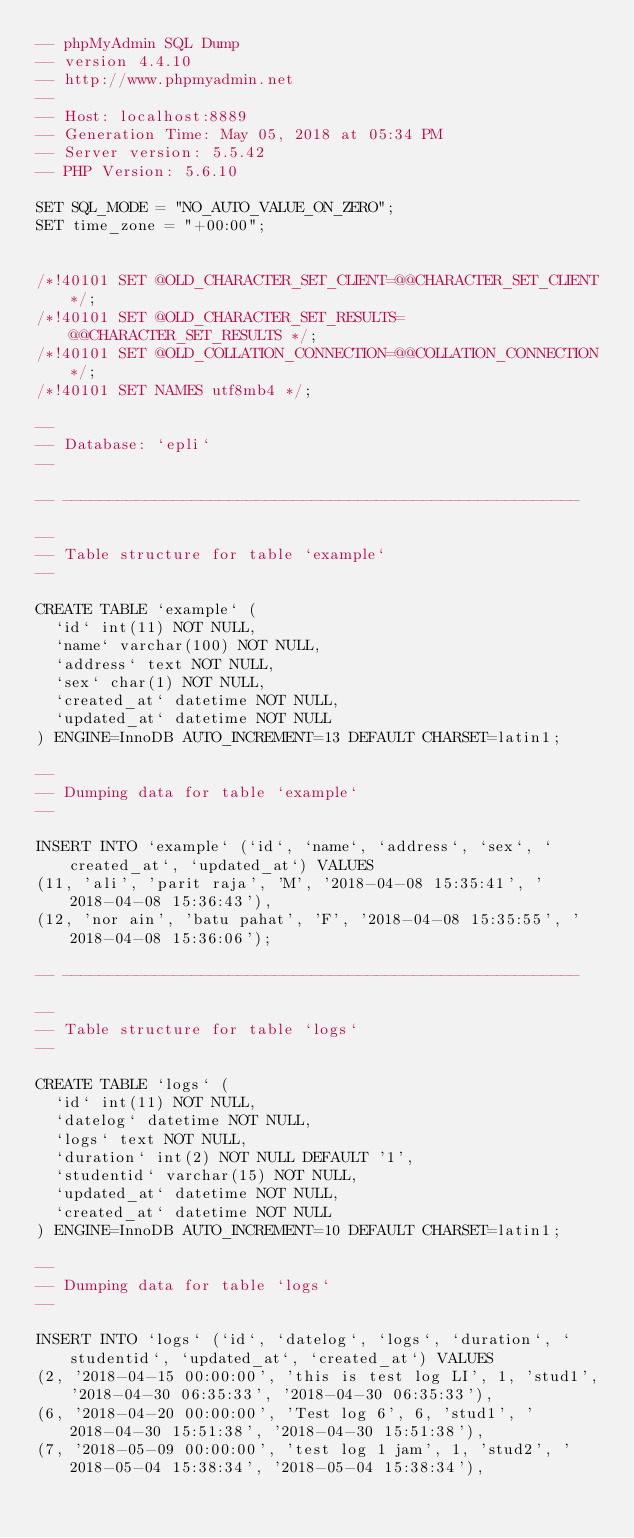Convert code to text. <code><loc_0><loc_0><loc_500><loc_500><_SQL_>-- phpMyAdmin SQL Dump
-- version 4.4.10
-- http://www.phpmyadmin.net
--
-- Host: localhost:8889
-- Generation Time: May 05, 2018 at 05:34 PM
-- Server version: 5.5.42
-- PHP Version: 5.6.10

SET SQL_MODE = "NO_AUTO_VALUE_ON_ZERO";
SET time_zone = "+00:00";


/*!40101 SET @OLD_CHARACTER_SET_CLIENT=@@CHARACTER_SET_CLIENT */;
/*!40101 SET @OLD_CHARACTER_SET_RESULTS=@@CHARACTER_SET_RESULTS */;
/*!40101 SET @OLD_COLLATION_CONNECTION=@@COLLATION_CONNECTION */;
/*!40101 SET NAMES utf8mb4 */;

--
-- Database: `epli`
--

-- --------------------------------------------------------

--
-- Table structure for table `example`
--

CREATE TABLE `example` (
  `id` int(11) NOT NULL,
  `name` varchar(100) NOT NULL,
  `address` text NOT NULL,
  `sex` char(1) NOT NULL,
  `created_at` datetime NOT NULL,
  `updated_at` datetime NOT NULL
) ENGINE=InnoDB AUTO_INCREMENT=13 DEFAULT CHARSET=latin1;

--
-- Dumping data for table `example`
--

INSERT INTO `example` (`id`, `name`, `address`, `sex`, `created_at`, `updated_at`) VALUES
(11, 'ali', 'parit raja', 'M', '2018-04-08 15:35:41', '2018-04-08 15:36:43'),
(12, 'nor ain', 'batu pahat', 'F', '2018-04-08 15:35:55', '2018-04-08 15:36:06');

-- --------------------------------------------------------

--
-- Table structure for table `logs`
--

CREATE TABLE `logs` (
  `id` int(11) NOT NULL,
  `datelog` datetime NOT NULL,
  `logs` text NOT NULL,
  `duration` int(2) NOT NULL DEFAULT '1',
  `studentid` varchar(15) NOT NULL,
  `updated_at` datetime NOT NULL,
  `created_at` datetime NOT NULL
) ENGINE=InnoDB AUTO_INCREMENT=10 DEFAULT CHARSET=latin1;

--
-- Dumping data for table `logs`
--

INSERT INTO `logs` (`id`, `datelog`, `logs`, `duration`, `studentid`, `updated_at`, `created_at`) VALUES
(2, '2018-04-15 00:00:00', 'this is test log LI', 1, 'stud1', '2018-04-30 06:35:33', '2018-04-30 06:35:33'),
(6, '2018-04-20 00:00:00', 'Test log 6', 6, 'stud1', '2018-04-30 15:51:38', '2018-04-30 15:51:38'),
(7, '2018-05-09 00:00:00', 'test log 1 jam', 1, 'stud2', '2018-05-04 15:38:34', '2018-05-04 15:38:34'),</code> 